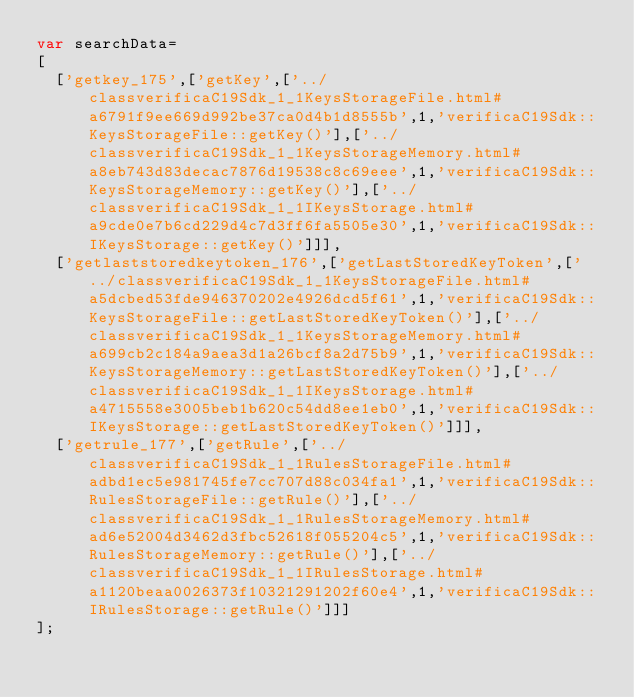<code> <loc_0><loc_0><loc_500><loc_500><_JavaScript_>var searchData=
[
  ['getkey_175',['getKey',['../classverificaC19Sdk_1_1KeysStorageFile.html#a6791f9ee669d992be37ca0d4b1d8555b',1,'verificaC19Sdk::KeysStorageFile::getKey()'],['../classverificaC19Sdk_1_1KeysStorageMemory.html#a8eb743d83decac7876d19538c8c69eee',1,'verificaC19Sdk::KeysStorageMemory::getKey()'],['../classverificaC19Sdk_1_1IKeysStorage.html#a9cde0e7b6cd229d4c7d3ff6fa5505e30',1,'verificaC19Sdk::IKeysStorage::getKey()']]],
  ['getlaststoredkeytoken_176',['getLastStoredKeyToken',['../classverificaC19Sdk_1_1KeysStorageFile.html#a5dcbed53fde946370202e4926dcd5f61',1,'verificaC19Sdk::KeysStorageFile::getLastStoredKeyToken()'],['../classverificaC19Sdk_1_1KeysStorageMemory.html#a699cb2c184a9aea3d1a26bcf8a2d75b9',1,'verificaC19Sdk::KeysStorageMemory::getLastStoredKeyToken()'],['../classverificaC19Sdk_1_1IKeysStorage.html#a4715558e3005beb1b620c54dd8ee1eb0',1,'verificaC19Sdk::IKeysStorage::getLastStoredKeyToken()']]],
  ['getrule_177',['getRule',['../classverificaC19Sdk_1_1RulesStorageFile.html#adbd1ec5e981745fe7cc707d88c034fa1',1,'verificaC19Sdk::RulesStorageFile::getRule()'],['../classverificaC19Sdk_1_1RulesStorageMemory.html#ad6e52004d3462d3fbc52618f055204c5',1,'verificaC19Sdk::RulesStorageMemory::getRule()'],['../classverificaC19Sdk_1_1IRulesStorage.html#a1120beaa0026373f10321291202f60e4',1,'verificaC19Sdk::IRulesStorage::getRule()']]]
];
</code> 